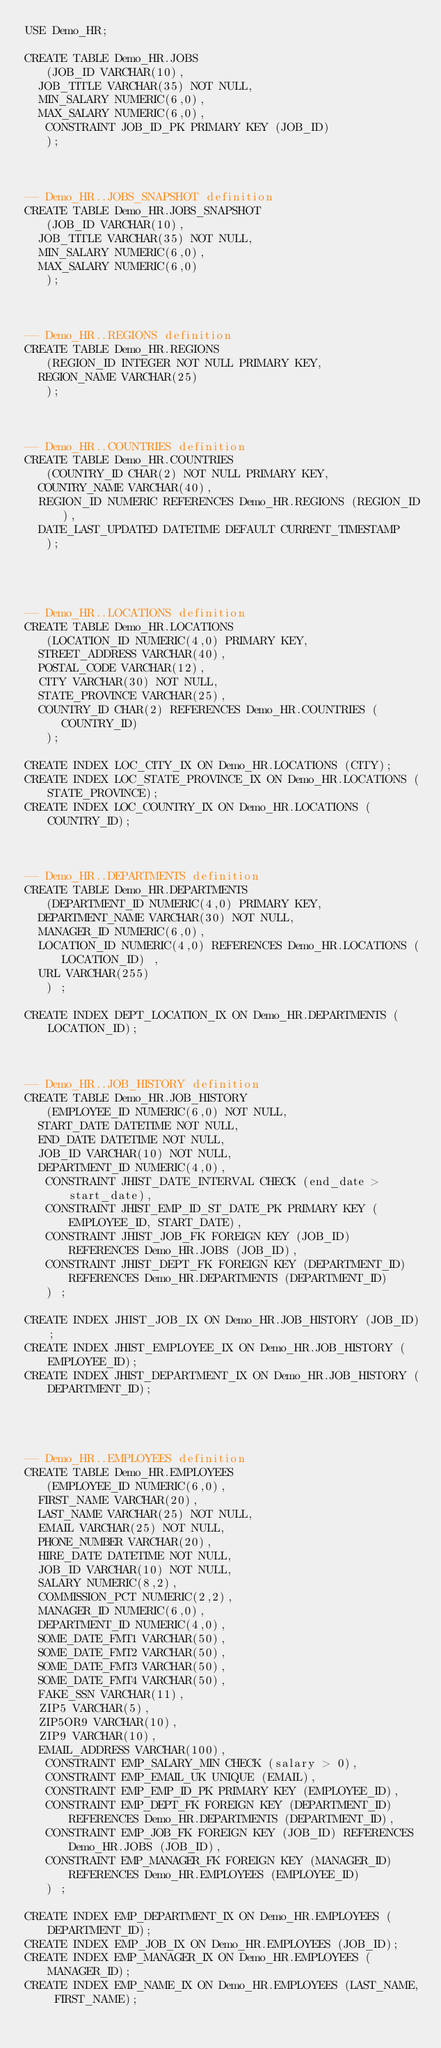Convert code to text. <code><loc_0><loc_0><loc_500><loc_500><_SQL_>USE Demo_HR;

CREATE TABLE Demo_HR.JOBS 
   (JOB_ID VARCHAR(10), 
	JOB_TITLE VARCHAR(35) NOT NULL, 
	MIN_SALARY NUMERIC(6,0), 
	MAX_SALARY NUMERIC(6,0), 
	 CONSTRAINT JOB_ID_PK PRIMARY KEY (JOB_ID)
   );



-- Demo_HR..JOBS_SNAPSHOT definition
CREATE TABLE Demo_HR.JOBS_SNAPSHOT 
   (JOB_ID VARCHAR(10), 
	JOB_TITLE VARCHAR(35) NOT NULL, 
	MIN_SALARY NUMERIC(6,0), 
	MAX_SALARY NUMERIC(6,0)
   );


  
-- Demo_HR..REGIONS definition
CREATE TABLE Demo_HR.REGIONS 
   (REGION_ID INTEGER NOT NULL PRIMARY KEY, 
	REGION_NAME VARCHAR(25) 
   );



-- Demo_HR..COUNTRIES definition
CREATE TABLE Demo_HR.COUNTRIES 
   (COUNTRY_ID CHAR(2) NOT NULL PRIMARY KEY, 
	COUNTRY_NAME VARCHAR(40), 
	REGION_ID NUMERIC REFERENCES Demo_HR.REGIONS (REGION_ID), 
	DATE_LAST_UPDATED DATETIME DEFAULT CURRENT_TIMESTAMP 
   );




-- Demo_HR..LOCATIONS definition
CREATE TABLE Demo_HR.LOCATIONS 
   (LOCATION_ID NUMERIC(4,0) PRIMARY KEY,  
	STREET_ADDRESS VARCHAR(40), 
	POSTAL_CODE VARCHAR(12), 
	CITY VARCHAR(30) NOT NULL, 
	STATE_PROVINCE VARCHAR(25), 
	COUNTRY_ID CHAR(2) REFERENCES Demo_HR.COUNTRIES (COUNTRY_ID)
   );

CREATE INDEX LOC_CITY_IX ON Demo_HR.LOCATIONS (CITY);
CREATE INDEX LOC_STATE_PROVINCE_IX ON Demo_HR.LOCATIONS (STATE_PROVINCE);
CREATE INDEX LOC_COUNTRY_IX ON Demo_HR.LOCATIONS (COUNTRY_ID);



-- Demo_HR..DEPARTMENTS definition
CREATE TABLE Demo_HR.DEPARTMENTS 
   (DEPARTMENT_ID NUMERIC(4,0) PRIMARY KEY, 
	DEPARTMENT_NAME VARCHAR(30) NOT NULL, 
	MANAGER_ID NUMERIC(6,0), 
	LOCATION_ID NUMERIC(4,0) REFERENCES Demo_HR.LOCATIONS (LOCATION_ID) ,
	URL VARCHAR(255) 
   ) ;

CREATE INDEX DEPT_LOCATION_IX ON Demo_HR.DEPARTMENTS (LOCATION_ID);



-- Demo_HR..JOB_HISTORY definition
CREATE TABLE Demo_HR.JOB_HISTORY 
   (EMPLOYEE_ID NUMERIC(6,0) NOT NULL, 
	START_DATE DATETIME NOT NULL, 
	END_DATE DATETIME NOT NULL, 
	JOB_ID VARCHAR(10) NOT NULL, 
	DEPARTMENT_ID NUMERIC(4,0), 
	 CONSTRAINT JHIST_DATE_INTERVAL CHECK (end_date > start_date), 
	 CONSTRAINT JHIST_EMP_ID_ST_DATE_PK PRIMARY KEY (EMPLOYEE_ID, START_DATE), 
	 CONSTRAINT JHIST_JOB_FK FOREIGN KEY (JOB_ID) REFERENCES Demo_HR.JOBS (JOB_ID), 
	 CONSTRAINT JHIST_DEPT_FK FOREIGN KEY (DEPARTMENT_ID) REFERENCES Demo_HR.DEPARTMENTS (DEPARTMENT_ID)
   ) ;

CREATE INDEX JHIST_JOB_IX ON Demo_HR.JOB_HISTORY (JOB_ID);
CREATE INDEX JHIST_EMPLOYEE_IX ON Demo_HR.JOB_HISTORY (EMPLOYEE_ID);
CREATE INDEX JHIST_DEPARTMENT_IX ON Demo_HR.JOB_HISTORY (DEPARTMENT_ID);




-- Demo_HR..EMPLOYEES definition
CREATE TABLE Demo_HR.EMPLOYEES 
   (EMPLOYEE_ID NUMERIC(6,0), 
	FIRST_NAME VARCHAR(20), 
	LAST_NAME VARCHAR(25) NOT NULL, 
	EMAIL VARCHAR(25) NOT NULL, 
	PHONE_NUMBER VARCHAR(20), 
	HIRE_DATE DATETIME NOT NULL, 
	JOB_ID VARCHAR(10) NOT NULL, 
	SALARY NUMERIC(8,2), 
	COMMISSION_PCT NUMERIC(2,2), 
	MANAGER_ID NUMERIC(6,0), 
	DEPARTMENT_ID NUMERIC(4,0), 
	SOME_DATE_FMT1 VARCHAR(50), 
	SOME_DATE_FMT2 VARCHAR(50), 
	SOME_DATE_FMT3 VARCHAR(50), 
	SOME_DATE_FMT4 VARCHAR(50), 
	FAKE_SSN VARCHAR(11), 
	ZIP5 VARCHAR(5), 
	ZIP5OR9 VARCHAR(10), 
	ZIP9 VARCHAR(10), 
	EMAIL_ADDRESS VARCHAR(100), 
	 CONSTRAINT EMP_SALARY_MIN CHECK (salary > 0), 
	 CONSTRAINT EMP_EMAIL_UK UNIQUE (EMAIL), 
	 CONSTRAINT EMP_EMP_ID_PK PRIMARY KEY (EMPLOYEE_ID), 
	 CONSTRAINT EMP_DEPT_FK FOREIGN KEY (DEPARTMENT_ID) REFERENCES Demo_HR.DEPARTMENTS (DEPARTMENT_ID), 
	 CONSTRAINT EMP_JOB_FK FOREIGN KEY (JOB_ID) REFERENCES Demo_HR.JOBS (JOB_ID), 
	 CONSTRAINT EMP_MANAGER_FK FOREIGN KEY (MANAGER_ID) REFERENCES Demo_HR.EMPLOYEES (EMPLOYEE_ID)
   ) ;

CREATE INDEX EMP_DEPARTMENT_IX ON Demo_HR.EMPLOYEES (DEPARTMENT_ID);
CREATE INDEX EMP_JOB_IX ON Demo_HR.EMPLOYEES (JOB_ID);
CREATE INDEX EMP_MANAGER_IX ON Demo_HR.EMPLOYEES (MANAGER_ID);
CREATE INDEX EMP_NAME_IX ON Demo_HR.EMPLOYEES (LAST_NAME, FIRST_NAME);






</code> 